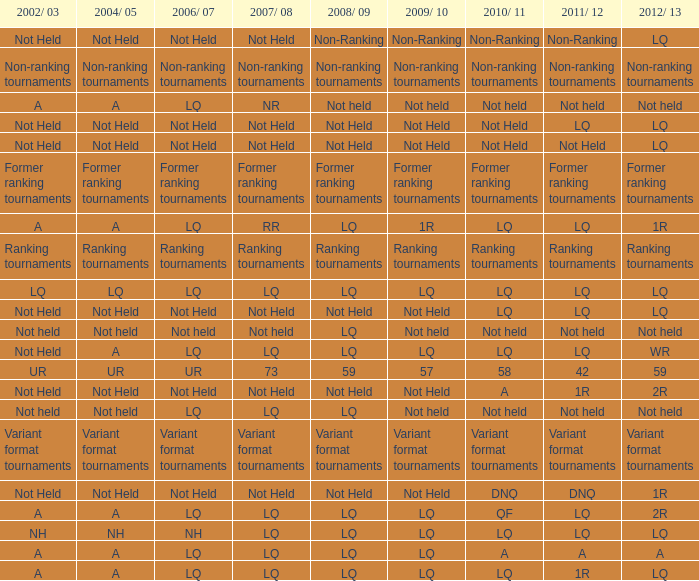Name the 2010/11 with 2004/05 of not held and 2011/12 of non-ranking Non-Ranking. 